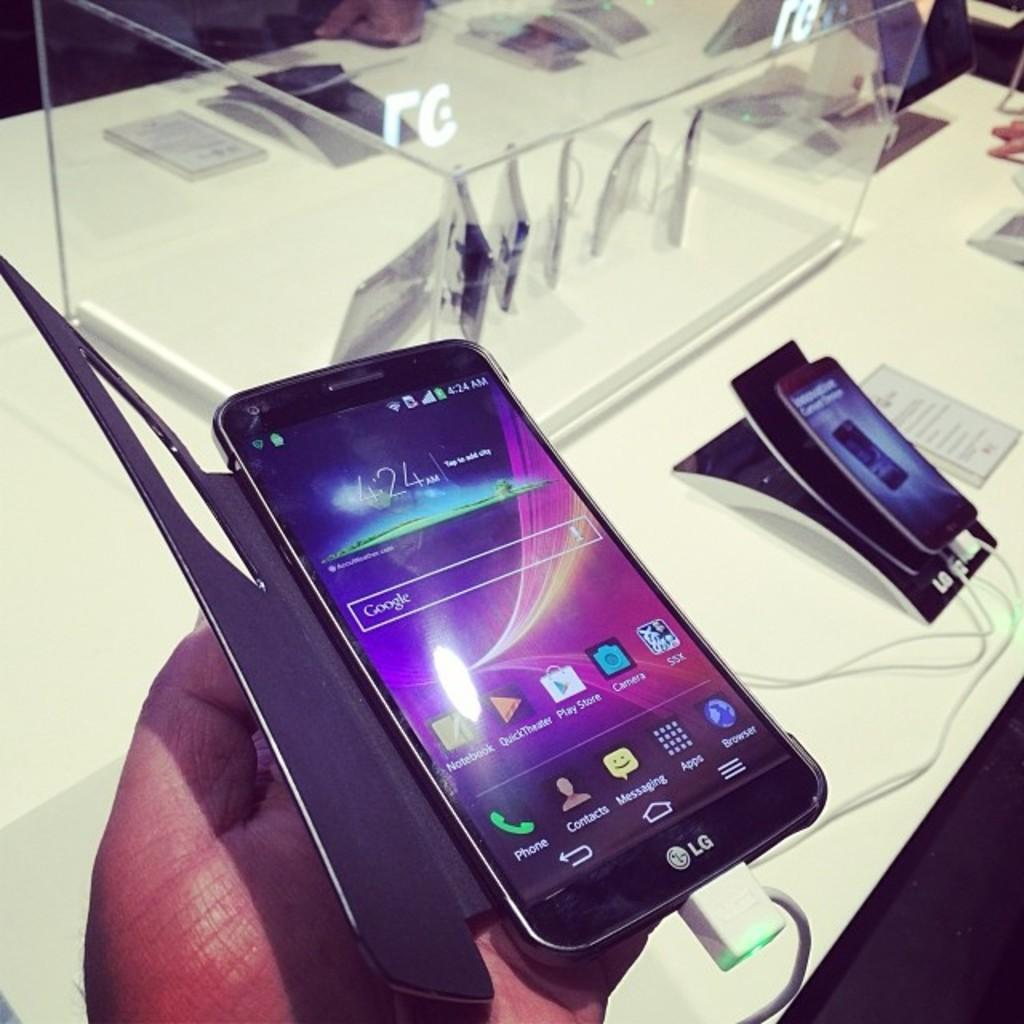Provide a one-sentence caption for the provided image. New curved LG smartphone with a case on it in a store at a hands on display. 